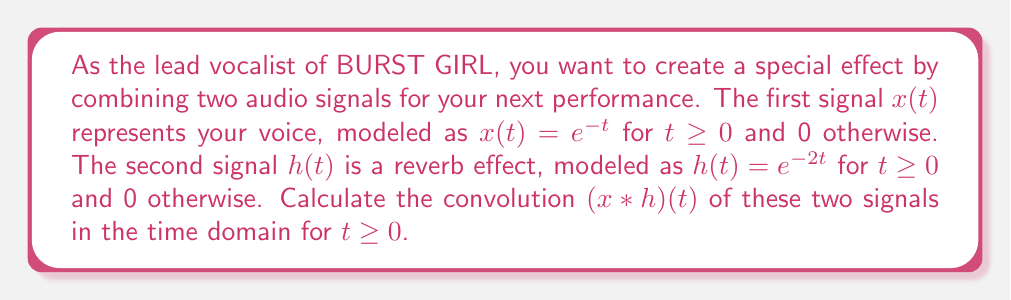What is the answer to this math problem? To calculate the convolution of two signals in the time domain, we use the convolution integral:

$$(x * h)(t) = \int_{-\infty}^{\infty} x(\tau)h(t-\tau)d\tau$$

Given:
$x(t) = e^{-t}$ for $t \geq 0$ and 0 otherwise
$h(t) = e^{-2t}$ for $t \geq 0$ and 0 otherwise

Step 1: Set up the convolution integral with the correct limits.
Since both signals are 0 for $t < 0$, we can change the lower limit to 0:

$$(x * h)(t) = \int_{0}^{t} x(\tau)h(t-\tau)d\tau$$

Step 2: Substitute the expressions for $x(\tau)$ and $h(t-\tau)$:

$$(x * h)(t) = \int_{0}^{t} e^{-\tau} \cdot e^{-2(t-\tau)}d\tau$$

Step 3: Simplify the integrand:

$$(x * h)(t) = \int_{0}^{t} e^{-\tau} \cdot e^{-2t+2\tau}d\tau = e^{-2t}\int_{0}^{t} e^{\tau}d\tau$$

Step 4: Evaluate the integral:

$$(x * h)(t) = e^{-2t}[e^{\tau}]_{0}^{t} = e^{-2t}(e^t - 1)$$

Step 5: Simplify the final expression:

$$(x * h)(t) = e^{-t} - e^{-2t}$$

This is the final result of the convolution for $t \geq 0$.
Answer: $(x * h)(t) = e^{-t} - e^{-2t}$ for $t \geq 0$ 